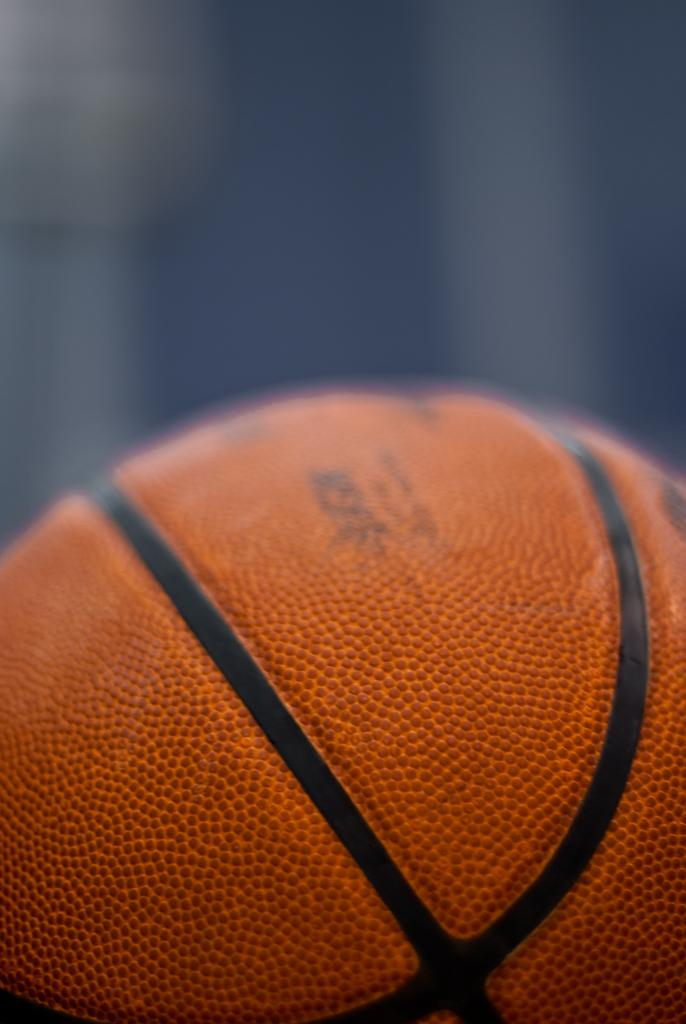What is the main object in the image? There is a basketball in the image. Can you describe the background of the image? The background of the image is blurred. What type of vessel is visible in the image? There is no vessel present in the image. Are there any sails visible in the image? There are no sails present in the image. Can you see any eggs in the image? There are no eggs present in the image. 